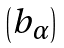Convert formula to latex. <formula><loc_0><loc_0><loc_500><loc_500>\begin{pmatrix} b _ { \alpha } \end{pmatrix}</formula> 